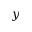<formula> <loc_0><loc_0><loc_500><loc_500>y</formula> 